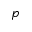Convert formula to latex. <formula><loc_0><loc_0><loc_500><loc_500>p</formula> 